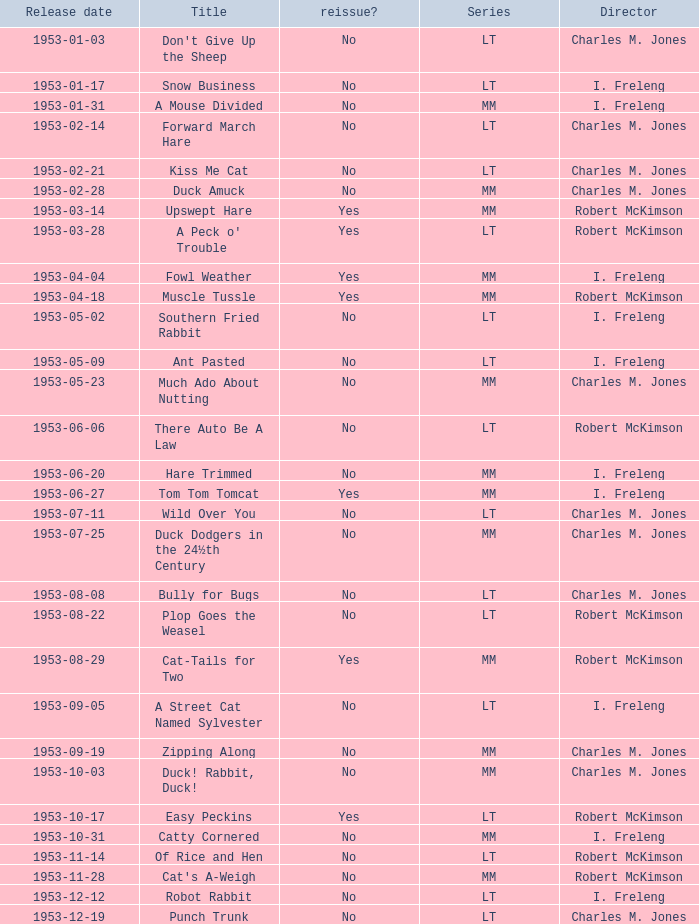What's the release date of Forward March Hare? 1953-02-14. 